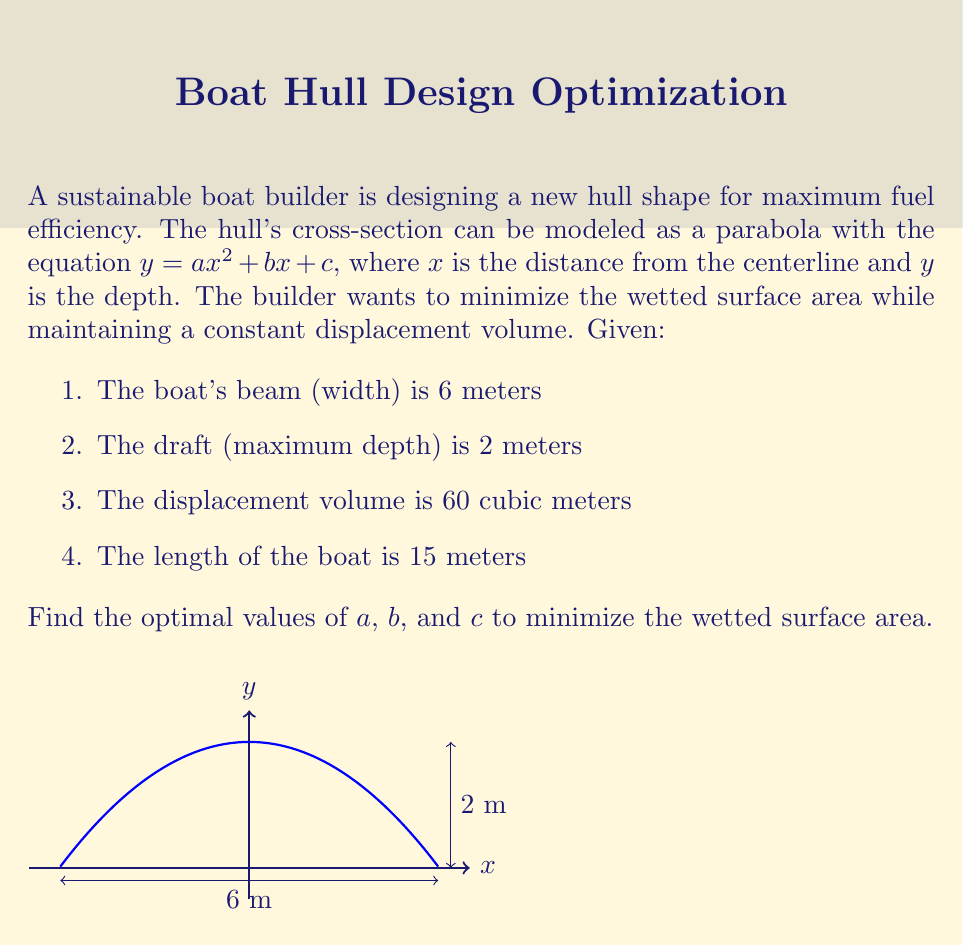Can you answer this question? Let's approach this step-by-step:

1) First, we need to set up our constraints:
   
   a) The parabola passes through (0, 2) and (3, 0):
      $2 = c$ and $0 = 9a + 3b + c$
   
   b) The area under the curve (displacement) is 60/15 = 4 m² per unit length:
      $\int_{-3}^{3} (ax^2 + bx + c) dx = 4$

2) From the first constraint:
   $c = 2$ and $9a + 3b + 2 = 0$

3) The area constraint gives us:
   $\int_{-3}^{3} (ax^2 + bx + 2) dx = 4$
   $[ax^3/3 + bx^2/2 + 2x]_{-3}^{3} = 4$
   $18a + 12 = 4$
   $18a = -8$
   $a = -4/9 \approx -0.44$

4) Substituting this back into $9a + 3b + 2 = 0$:
   $9(-4/9) + 3b + 2 = 0$
   $-4 + 3b + 2 = 0$
   $3b = 2$
   $b = 2/3 \approx 0.67$

5) The wetted surface area is given by the arc length formula:
   $S = \int_{-3}^{3} \sqrt{1 + (y')^2} dx$
   where $y' = 2ax + b$

6) To minimize S, we need to minimize $\int_{-3}^{3} \sqrt{1 + (2ax + b)^2} dx$

7) This integral doesn't have a simple analytical solution, but we can see that minimizing $a$ and $b$ will minimize the surface area.

8) Therefore, the optimal values are:
   $a = -4/9$
   $b = 2/3$
   $c = 2$
Answer: $a = -4/9$, $b = 2/3$, $c = 2$ 